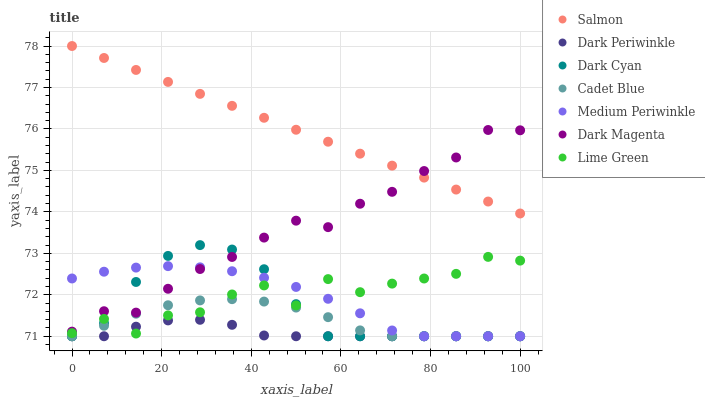Does Dark Periwinkle have the minimum area under the curve?
Answer yes or no. Yes. Does Salmon have the maximum area under the curve?
Answer yes or no. Yes. Does Dark Magenta have the minimum area under the curve?
Answer yes or no. No. Does Dark Magenta have the maximum area under the curve?
Answer yes or no. No. Is Salmon the smoothest?
Answer yes or no. Yes. Is Lime Green the roughest?
Answer yes or no. Yes. Is Dark Magenta the smoothest?
Answer yes or no. No. Is Dark Magenta the roughest?
Answer yes or no. No. Does Cadet Blue have the lowest value?
Answer yes or no. Yes. Does Dark Magenta have the lowest value?
Answer yes or no. No. Does Salmon have the highest value?
Answer yes or no. Yes. Does Dark Magenta have the highest value?
Answer yes or no. No. Is Cadet Blue less than Dark Magenta?
Answer yes or no. Yes. Is Dark Magenta greater than Lime Green?
Answer yes or no. Yes. Does Dark Cyan intersect Medium Periwinkle?
Answer yes or no. Yes. Is Dark Cyan less than Medium Periwinkle?
Answer yes or no. No. Is Dark Cyan greater than Medium Periwinkle?
Answer yes or no. No. Does Cadet Blue intersect Dark Magenta?
Answer yes or no. No. 